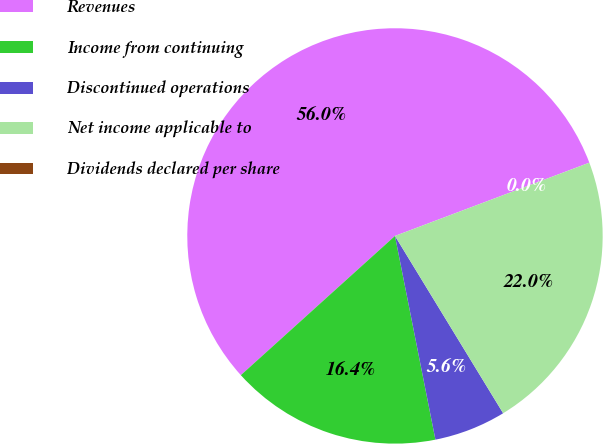Convert chart to OTSL. <chart><loc_0><loc_0><loc_500><loc_500><pie_chart><fcel>Revenues<fcel>Income from continuing<fcel>Discontinued operations<fcel>Net income applicable to<fcel>Dividends declared per share<nl><fcel>55.96%<fcel>16.43%<fcel>5.6%<fcel>22.02%<fcel>0.0%<nl></chart> 